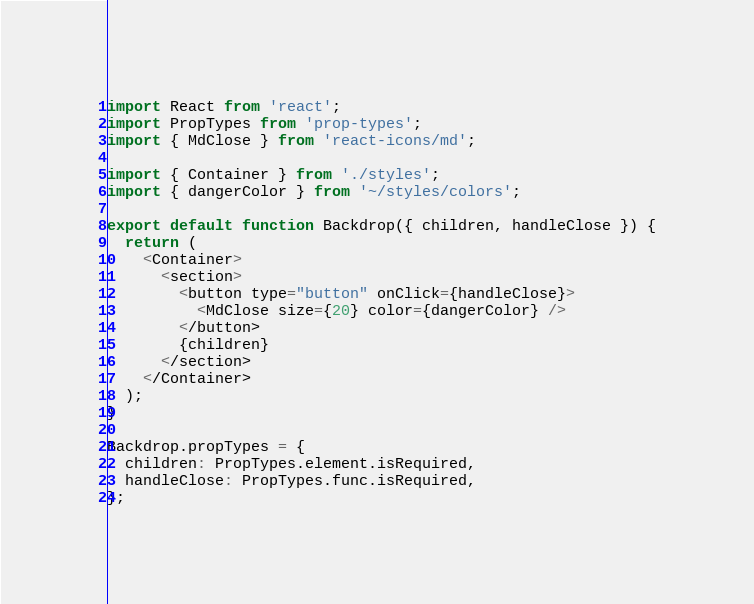<code> <loc_0><loc_0><loc_500><loc_500><_JavaScript_>import React from 'react';
import PropTypes from 'prop-types';
import { MdClose } from 'react-icons/md';

import { Container } from './styles';
import { dangerColor } from '~/styles/colors';

export default function Backdrop({ children, handleClose }) {
  return (
    <Container>
      <section>
        <button type="button" onClick={handleClose}>
          <MdClose size={20} color={dangerColor} />
        </button>
        {children}
      </section>
    </Container>
  );
}

Backdrop.propTypes = {
  children: PropTypes.element.isRequired,
  handleClose: PropTypes.func.isRequired,
};
</code> 